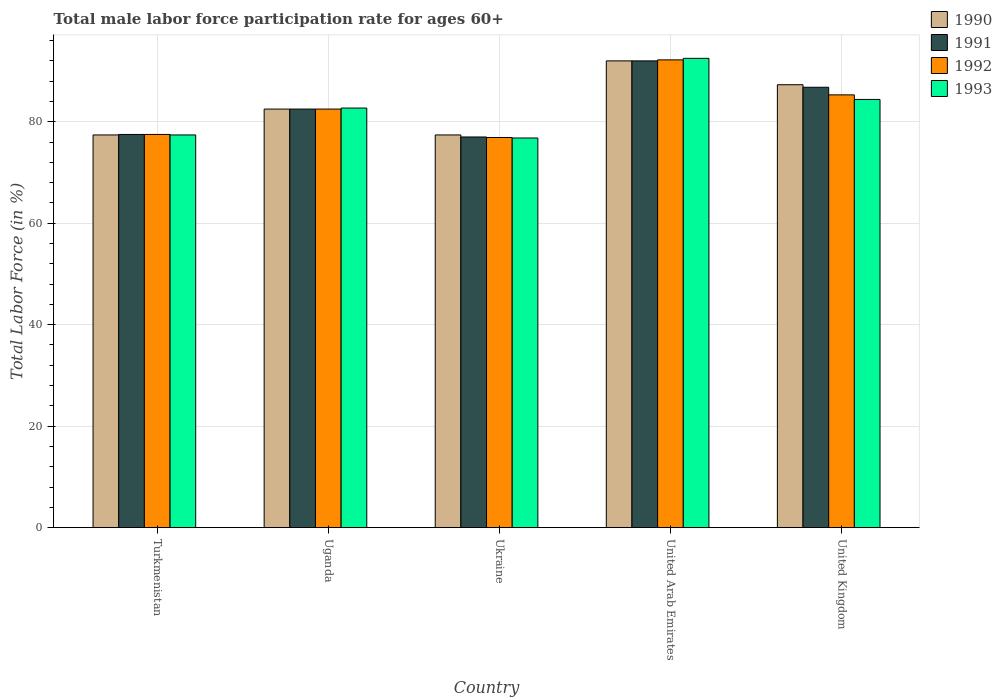How many groups of bars are there?
Keep it short and to the point. 5. Are the number of bars per tick equal to the number of legend labels?
Make the answer very short. Yes. Are the number of bars on each tick of the X-axis equal?
Provide a short and direct response. Yes. How many bars are there on the 1st tick from the left?
Your answer should be compact. 4. What is the label of the 3rd group of bars from the left?
Provide a short and direct response. Ukraine. In how many cases, is the number of bars for a given country not equal to the number of legend labels?
Offer a terse response. 0. What is the male labor force participation rate in 1990 in Turkmenistan?
Your answer should be compact. 77.4. Across all countries, what is the maximum male labor force participation rate in 1990?
Your response must be concise. 92. Across all countries, what is the minimum male labor force participation rate in 1993?
Ensure brevity in your answer.  76.8. In which country was the male labor force participation rate in 1991 maximum?
Make the answer very short. United Arab Emirates. In which country was the male labor force participation rate in 1993 minimum?
Give a very brief answer. Ukraine. What is the total male labor force participation rate in 1992 in the graph?
Make the answer very short. 414.4. What is the difference between the male labor force participation rate in 1990 in Turkmenistan and that in Uganda?
Provide a succinct answer. -5.1. What is the difference between the male labor force participation rate in 1993 in Ukraine and the male labor force participation rate in 1991 in Turkmenistan?
Ensure brevity in your answer.  -0.7. What is the average male labor force participation rate in 1991 per country?
Provide a short and direct response. 83.16. What is the difference between the male labor force participation rate of/in 1992 and male labor force participation rate of/in 1993 in Uganda?
Offer a very short reply. -0.2. In how many countries, is the male labor force participation rate in 1992 greater than 92 %?
Provide a short and direct response. 1. What is the ratio of the male labor force participation rate in 1993 in Turkmenistan to that in United Kingdom?
Keep it short and to the point. 0.92. Is the male labor force participation rate in 1993 in Uganda less than that in Ukraine?
Your answer should be very brief. No. What is the difference between the highest and the second highest male labor force participation rate in 1991?
Your answer should be very brief. -9.5. What is the difference between the highest and the lowest male labor force participation rate in 1990?
Your answer should be compact. 14.6. Is the sum of the male labor force participation rate in 1991 in Turkmenistan and United Arab Emirates greater than the maximum male labor force participation rate in 1990 across all countries?
Your answer should be compact. Yes. What does the 2nd bar from the left in United Kingdom represents?
Keep it short and to the point. 1991. Is it the case that in every country, the sum of the male labor force participation rate in 1993 and male labor force participation rate in 1991 is greater than the male labor force participation rate in 1990?
Your response must be concise. Yes. How many bars are there?
Give a very brief answer. 20. Are all the bars in the graph horizontal?
Provide a succinct answer. No. Are the values on the major ticks of Y-axis written in scientific E-notation?
Make the answer very short. No. Does the graph contain any zero values?
Provide a succinct answer. No. Does the graph contain grids?
Give a very brief answer. Yes. Where does the legend appear in the graph?
Your answer should be very brief. Top right. How many legend labels are there?
Offer a very short reply. 4. How are the legend labels stacked?
Keep it short and to the point. Vertical. What is the title of the graph?
Provide a succinct answer. Total male labor force participation rate for ages 60+. What is the label or title of the X-axis?
Ensure brevity in your answer.  Country. What is the label or title of the Y-axis?
Make the answer very short. Total Labor Force (in %). What is the Total Labor Force (in %) in 1990 in Turkmenistan?
Ensure brevity in your answer.  77.4. What is the Total Labor Force (in %) of 1991 in Turkmenistan?
Your response must be concise. 77.5. What is the Total Labor Force (in %) in 1992 in Turkmenistan?
Provide a succinct answer. 77.5. What is the Total Labor Force (in %) of 1993 in Turkmenistan?
Your answer should be very brief. 77.4. What is the Total Labor Force (in %) of 1990 in Uganda?
Your answer should be compact. 82.5. What is the Total Labor Force (in %) in 1991 in Uganda?
Provide a short and direct response. 82.5. What is the Total Labor Force (in %) of 1992 in Uganda?
Offer a terse response. 82.5. What is the Total Labor Force (in %) of 1993 in Uganda?
Ensure brevity in your answer.  82.7. What is the Total Labor Force (in %) of 1990 in Ukraine?
Provide a short and direct response. 77.4. What is the Total Labor Force (in %) in 1991 in Ukraine?
Offer a very short reply. 77. What is the Total Labor Force (in %) of 1992 in Ukraine?
Offer a terse response. 76.9. What is the Total Labor Force (in %) in 1993 in Ukraine?
Give a very brief answer. 76.8. What is the Total Labor Force (in %) of 1990 in United Arab Emirates?
Provide a short and direct response. 92. What is the Total Labor Force (in %) of 1991 in United Arab Emirates?
Provide a succinct answer. 92. What is the Total Labor Force (in %) of 1992 in United Arab Emirates?
Your answer should be compact. 92.2. What is the Total Labor Force (in %) of 1993 in United Arab Emirates?
Your response must be concise. 92.5. What is the Total Labor Force (in %) of 1990 in United Kingdom?
Your answer should be compact. 87.3. What is the Total Labor Force (in %) in 1991 in United Kingdom?
Your answer should be compact. 86.8. What is the Total Labor Force (in %) of 1992 in United Kingdom?
Give a very brief answer. 85.3. What is the Total Labor Force (in %) of 1993 in United Kingdom?
Your answer should be very brief. 84.4. Across all countries, what is the maximum Total Labor Force (in %) of 1990?
Provide a succinct answer. 92. Across all countries, what is the maximum Total Labor Force (in %) in 1991?
Provide a short and direct response. 92. Across all countries, what is the maximum Total Labor Force (in %) of 1992?
Offer a terse response. 92.2. Across all countries, what is the maximum Total Labor Force (in %) in 1993?
Provide a short and direct response. 92.5. Across all countries, what is the minimum Total Labor Force (in %) of 1990?
Keep it short and to the point. 77.4. Across all countries, what is the minimum Total Labor Force (in %) in 1992?
Keep it short and to the point. 76.9. Across all countries, what is the minimum Total Labor Force (in %) in 1993?
Offer a very short reply. 76.8. What is the total Total Labor Force (in %) in 1990 in the graph?
Give a very brief answer. 416.6. What is the total Total Labor Force (in %) in 1991 in the graph?
Offer a terse response. 415.8. What is the total Total Labor Force (in %) in 1992 in the graph?
Offer a terse response. 414.4. What is the total Total Labor Force (in %) of 1993 in the graph?
Keep it short and to the point. 413.8. What is the difference between the Total Labor Force (in %) in 1990 in Turkmenistan and that in Uganda?
Ensure brevity in your answer.  -5.1. What is the difference between the Total Labor Force (in %) in 1992 in Turkmenistan and that in Uganda?
Keep it short and to the point. -5. What is the difference between the Total Labor Force (in %) of 1991 in Turkmenistan and that in Ukraine?
Make the answer very short. 0.5. What is the difference between the Total Labor Force (in %) in 1992 in Turkmenistan and that in Ukraine?
Keep it short and to the point. 0.6. What is the difference between the Total Labor Force (in %) of 1993 in Turkmenistan and that in Ukraine?
Offer a very short reply. 0.6. What is the difference between the Total Labor Force (in %) of 1990 in Turkmenistan and that in United Arab Emirates?
Keep it short and to the point. -14.6. What is the difference between the Total Labor Force (in %) of 1992 in Turkmenistan and that in United Arab Emirates?
Your response must be concise. -14.7. What is the difference between the Total Labor Force (in %) of 1993 in Turkmenistan and that in United Arab Emirates?
Offer a terse response. -15.1. What is the difference between the Total Labor Force (in %) of 1991 in Turkmenistan and that in United Kingdom?
Provide a succinct answer. -9.3. What is the difference between the Total Labor Force (in %) in 1990 in Uganda and that in Ukraine?
Make the answer very short. 5.1. What is the difference between the Total Labor Force (in %) of 1993 in Uganda and that in United Arab Emirates?
Keep it short and to the point. -9.8. What is the difference between the Total Labor Force (in %) in 1990 in Ukraine and that in United Arab Emirates?
Ensure brevity in your answer.  -14.6. What is the difference between the Total Labor Force (in %) of 1992 in Ukraine and that in United Arab Emirates?
Your response must be concise. -15.3. What is the difference between the Total Labor Force (in %) in 1993 in Ukraine and that in United Arab Emirates?
Ensure brevity in your answer.  -15.7. What is the difference between the Total Labor Force (in %) of 1990 in Ukraine and that in United Kingdom?
Provide a succinct answer. -9.9. What is the difference between the Total Labor Force (in %) in 1991 in Ukraine and that in United Kingdom?
Your answer should be very brief. -9.8. What is the difference between the Total Labor Force (in %) in 1990 in United Arab Emirates and that in United Kingdom?
Your answer should be very brief. 4.7. What is the difference between the Total Labor Force (in %) of 1992 in United Arab Emirates and that in United Kingdom?
Your response must be concise. 6.9. What is the difference between the Total Labor Force (in %) of 1993 in United Arab Emirates and that in United Kingdom?
Provide a succinct answer. 8.1. What is the difference between the Total Labor Force (in %) of 1990 in Turkmenistan and the Total Labor Force (in %) of 1991 in Uganda?
Your answer should be very brief. -5.1. What is the difference between the Total Labor Force (in %) of 1990 in Turkmenistan and the Total Labor Force (in %) of 1992 in Uganda?
Your answer should be very brief. -5.1. What is the difference between the Total Labor Force (in %) of 1990 in Turkmenistan and the Total Labor Force (in %) of 1993 in Uganda?
Keep it short and to the point. -5.3. What is the difference between the Total Labor Force (in %) in 1990 in Turkmenistan and the Total Labor Force (in %) in 1993 in Ukraine?
Make the answer very short. 0.6. What is the difference between the Total Labor Force (in %) in 1991 in Turkmenistan and the Total Labor Force (in %) in 1992 in Ukraine?
Your answer should be very brief. 0.6. What is the difference between the Total Labor Force (in %) of 1992 in Turkmenistan and the Total Labor Force (in %) of 1993 in Ukraine?
Offer a terse response. 0.7. What is the difference between the Total Labor Force (in %) in 1990 in Turkmenistan and the Total Labor Force (in %) in 1991 in United Arab Emirates?
Ensure brevity in your answer.  -14.6. What is the difference between the Total Labor Force (in %) in 1990 in Turkmenistan and the Total Labor Force (in %) in 1992 in United Arab Emirates?
Your answer should be very brief. -14.8. What is the difference between the Total Labor Force (in %) of 1990 in Turkmenistan and the Total Labor Force (in %) of 1993 in United Arab Emirates?
Your answer should be very brief. -15.1. What is the difference between the Total Labor Force (in %) in 1991 in Turkmenistan and the Total Labor Force (in %) in 1992 in United Arab Emirates?
Ensure brevity in your answer.  -14.7. What is the difference between the Total Labor Force (in %) in 1991 in Turkmenistan and the Total Labor Force (in %) in 1993 in United Arab Emirates?
Provide a succinct answer. -15. What is the difference between the Total Labor Force (in %) of 1992 in Turkmenistan and the Total Labor Force (in %) of 1993 in United Arab Emirates?
Provide a short and direct response. -15. What is the difference between the Total Labor Force (in %) in 1990 in Turkmenistan and the Total Labor Force (in %) in 1992 in United Kingdom?
Your response must be concise. -7.9. What is the difference between the Total Labor Force (in %) in 1991 in Turkmenistan and the Total Labor Force (in %) in 1993 in United Kingdom?
Keep it short and to the point. -6.9. What is the difference between the Total Labor Force (in %) in 1992 in Turkmenistan and the Total Labor Force (in %) in 1993 in United Kingdom?
Provide a short and direct response. -6.9. What is the difference between the Total Labor Force (in %) in 1990 in Uganda and the Total Labor Force (in %) in 1992 in Ukraine?
Keep it short and to the point. 5.6. What is the difference between the Total Labor Force (in %) of 1990 in Uganda and the Total Labor Force (in %) of 1993 in Ukraine?
Ensure brevity in your answer.  5.7. What is the difference between the Total Labor Force (in %) in 1991 in Uganda and the Total Labor Force (in %) in 1992 in Ukraine?
Give a very brief answer. 5.6. What is the difference between the Total Labor Force (in %) in 1990 in Uganda and the Total Labor Force (in %) in 1991 in United Arab Emirates?
Offer a terse response. -9.5. What is the difference between the Total Labor Force (in %) of 1991 in Uganda and the Total Labor Force (in %) of 1992 in United Arab Emirates?
Ensure brevity in your answer.  -9.7. What is the difference between the Total Labor Force (in %) of 1992 in Uganda and the Total Labor Force (in %) of 1993 in United Arab Emirates?
Your answer should be very brief. -10. What is the difference between the Total Labor Force (in %) in 1990 in Uganda and the Total Labor Force (in %) in 1992 in United Kingdom?
Offer a very short reply. -2.8. What is the difference between the Total Labor Force (in %) in 1991 in Uganda and the Total Labor Force (in %) in 1992 in United Kingdom?
Your response must be concise. -2.8. What is the difference between the Total Labor Force (in %) of 1992 in Uganda and the Total Labor Force (in %) of 1993 in United Kingdom?
Offer a very short reply. -1.9. What is the difference between the Total Labor Force (in %) in 1990 in Ukraine and the Total Labor Force (in %) in 1991 in United Arab Emirates?
Your answer should be compact. -14.6. What is the difference between the Total Labor Force (in %) in 1990 in Ukraine and the Total Labor Force (in %) in 1992 in United Arab Emirates?
Keep it short and to the point. -14.8. What is the difference between the Total Labor Force (in %) of 1990 in Ukraine and the Total Labor Force (in %) of 1993 in United Arab Emirates?
Make the answer very short. -15.1. What is the difference between the Total Labor Force (in %) of 1991 in Ukraine and the Total Labor Force (in %) of 1992 in United Arab Emirates?
Your answer should be very brief. -15.2. What is the difference between the Total Labor Force (in %) in 1991 in Ukraine and the Total Labor Force (in %) in 1993 in United Arab Emirates?
Ensure brevity in your answer.  -15.5. What is the difference between the Total Labor Force (in %) of 1992 in Ukraine and the Total Labor Force (in %) of 1993 in United Arab Emirates?
Offer a very short reply. -15.6. What is the difference between the Total Labor Force (in %) of 1990 in Ukraine and the Total Labor Force (in %) of 1992 in United Kingdom?
Offer a very short reply. -7.9. What is the difference between the Total Labor Force (in %) in 1990 in Ukraine and the Total Labor Force (in %) in 1993 in United Kingdom?
Offer a very short reply. -7. What is the difference between the Total Labor Force (in %) in 1992 in Ukraine and the Total Labor Force (in %) in 1993 in United Kingdom?
Your answer should be compact. -7.5. What is the difference between the Total Labor Force (in %) in 1990 in United Arab Emirates and the Total Labor Force (in %) in 1991 in United Kingdom?
Give a very brief answer. 5.2. What is the average Total Labor Force (in %) in 1990 per country?
Your response must be concise. 83.32. What is the average Total Labor Force (in %) in 1991 per country?
Make the answer very short. 83.16. What is the average Total Labor Force (in %) of 1992 per country?
Offer a very short reply. 82.88. What is the average Total Labor Force (in %) in 1993 per country?
Your answer should be compact. 82.76. What is the difference between the Total Labor Force (in %) of 1990 and Total Labor Force (in %) of 1991 in Turkmenistan?
Provide a short and direct response. -0.1. What is the difference between the Total Labor Force (in %) in 1991 and Total Labor Force (in %) in 1993 in Turkmenistan?
Your answer should be very brief. 0.1. What is the difference between the Total Labor Force (in %) in 1990 and Total Labor Force (in %) in 1991 in Uganda?
Provide a succinct answer. 0. What is the difference between the Total Labor Force (in %) of 1991 and Total Labor Force (in %) of 1992 in Uganda?
Provide a succinct answer. 0. What is the difference between the Total Labor Force (in %) in 1992 and Total Labor Force (in %) in 1993 in Uganda?
Your response must be concise. -0.2. What is the difference between the Total Labor Force (in %) of 1990 and Total Labor Force (in %) of 1991 in Ukraine?
Your answer should be very brief. 0.4. What is the difference between the Total Labor Force (in %) of 1990 and Total Labor Force (in %) of 1992 in Ukraine?
Offer a very short reply. 0.5. What is the difference between the Total Labor Force (in %) of 1992 and Total Labor Force (in %) of 1993 in Ukraine?
Give a very brief answer. 0.1. What is the difference between the Total Labor Force (in %) in 1990 and Total Labor Force (in %) in 1991 in United Arab Emirates?
Your answer should be compact. 0. What is the difference between the Total Labor Force (in %) of 1990 and Total Labor Force (in %) of 1992 in United Arab Emirates?
Offer a terse response. -0.2. What is the difference between the Total Labor Force (in %) in 1990 and Total Labor Force (in %) in 1993 in United Arab Emirates?
Ensure brevity in your answer.  -0.5. What is the difference between the Total Labor Force (in %) of 1992 and Total Labor Force (in %) of 1993 in United Arab Emirates?
Provide a succinct answer. -0.3. What is the difference between the Total Labor Force (in %) of 1990 and Total Labor Force (in %) of 1993 in United Kingdom?
Ensure brevity in your answer.  2.9. What is the difference between the Total Labor Force (in %) of 1991 and Total Labor Force (in %) of 1993 in United Kingdom?
Your response must be concise. 2.4. What is the ratio of the Total Labor Force (in %) of 1990 in Turkmenistan to that in Uganda?
Your response must be concise. 0.94. What is the ratio of the Total Labor Force (in %) of 1991 in Turkmenistan to that in Uganda?
Keep it short and to the point. 0.94. What is the ratio of the Total Labor Force (in %) of 1992 in Turkmenistan to that in Uganda?
Keep it short and to the point. 0.94. What is the ratio of the Total Labor Force (in %) of 1993 in Turkmenistan to that in Uganda?
Your answer should be compact. 0.94. What is the ratio of the Total Labor Force (in %) of 1992 in Turkmenistan to that in Ukraine?
Offer a terse response. 1.01. What is the ratio of the Total Labor Force (in %) in 1990 in Turkmenistan to that in United Arab Emirates?
Offer a terse response. 0.84. What is the ratio of the Total Labor Force (in %) in 1991 in Turkmenistan to that in United Arab Emirates?
Give a very brief answer. 0.84. What is the ratio of the Total Labor Force (in %) in 1992 in Turkmenistan to that in United Arab Emirates?
Provide a short and direct response. 0.84. What is the ratio of the Total Labor Force (in %) of 1993 in Turkmenistan to that in United Arab Emirates?
Your response must be concise. 0.84. What is the ratio of the Total Labor Force (in %) in 1990 in Turkmenistan to that in United Kingdom?
Your answer should be very brief. 0.89. What is the ratio of the Total Labor Force (in %) of 1991 in Turkmenistan to that in United Kingdom?
Give a very brief answer. 0.89. What is the ratio of the Total Labor Force (in %) in 1992 in Turkmenistan to that in United Kingdom?
Provide a succinct answer. 0.91. What is the ratio of the Total Labor Force (in %) of 1993 in Turkmenistan to that in United Kingdom?
Give a very brief answer. 0.92. What is the ratio of the Total Labor Force (in %) in 1990 in Uganda to that in Ukraine?
Keep it short and to the point. 1.07. What is the ratio of the Total Labor Force (in %) in 1991 in Uganda to that in Ukraine?
Your response must be concise. 1.07. What is the ratio of the Total Labor Force (in %) of 1992 in Uganda to that in Ukraine?
Ensure brevity in your answer.  1.07. What is the ratio of the Total Labor Force (in %) in 1993 in Uganda to that in Ukraine?
Ensure brevity in your answer.  1.08. What is the ratio of the Total Labor Force (in %) in 1990 in Uganda to that in United Arab Emirates?
Ensure brevity in your answer.  0.9. What is the ratio of the Total Labor Force (in %) of 1991 in Uganda to that in United Arab Emirates?
Provide a succinct answer. 0.9. What is the ratio of the Total Labor Force (in %) in 1992 in Uganda to that in United Arab Emirates?
Offer a terse response. 0.89. What is the ratio of the Total Labor Force (in %) of 1993 in Uganda to that in United Arab Emirates?
Offer a very short reply. 0.89. What is the ratio of the Total Labor Force (in %) in 1990 in Uganda to that in United Kingdom?
Offer a terse response. 0.94. What is the ratio of the Total Labor Force (in %) of 1991 in Uganda to that in United Kingdom?
Make the answer very short. 0.95. What is the ratio of the Total Labor Force (in %) of 1992 in Uganda to that in United Kingdom?
Offer a terse response. 0.97. What is the ratio of the Total Labor Force (in %) of 1993 in Uganda to that in United Kingdom?
Ensure brevity in your answer.  0.98. What is the ratio of the Total Labor Force (in %) in 1990 in Ukraine to that in United Arab Emirates?
Offer a very short reply. 0.84. What is the ratio of the Total Labor Force (in %) of 1991 in Ukraine to that in United Arab Emirates?
Keep it short and to the point. 0.84. What is the ratio of the Total Labor Force (in %) of 1992 in Ukraine to that in United Arab Emirates?
Ensure brevity in your answer.  0.83. What is the ratio of the Total Labor Force (in %) of 1993 in Ukraine to that in United Arab Emirates?
Provide a short and direct response. 0.83. What is the ratio of the Total Labor Force (in %) of 1990 in Ukraine to that in United Kingdom?
Make the answer very short. 0.89. What is the ratio of the Total Labor Force (in %) of 1991 in Ukraine to that in United Kingdom?
Give a very brief answer. 0.89. What is the ratio of the Total Labor Force (in %) of 1992 in Ukraine to that in United Kingdom?
Provide a succinct answer. 0.9. What is the ratio of the Total Labor Force (in %) of 1993 in Ukraine to that in United Kingdom?
Ensure brevity in your answer.  0.91. What is the ratio of the Total Labor Force (in %) in 1990 in United Arab Emirates to that in United Kingdom?
Provide a succinct answer. 1.05. What is the ratio of the Total Labor Force (in %) of 1991 in United Arab Emirates to that in United Kingdom?
Your answer should be very brief. 1.06. What is the ratio of the Total Labor Force (in %) of 1992 in United Arab Emirates to that in United Kingdom?
Your answer should be compact. 1.08. What is the ratio of the Total Labor Force (in %) in 1993 in United Arab Emirates to that in United Kingdom?
Make the answer very short. 1.1. What is the difference between the highest and the second highest Total Labor Force (in %) in 1991?
Offer a very short reply. 5.2. What is the difference between the highest and the lowest Total Labor Force (in %) of 1990?
Ensure brevity in your answer.  14.6. What is the difference between the highest and the lowest Total Labor Force (in %) in 1992?
Offer a very short reply. 15.3. What is the difference between the highest and the lowest Total Labor Force (in %) in 1993?
Offer a terse response. 15.7. 